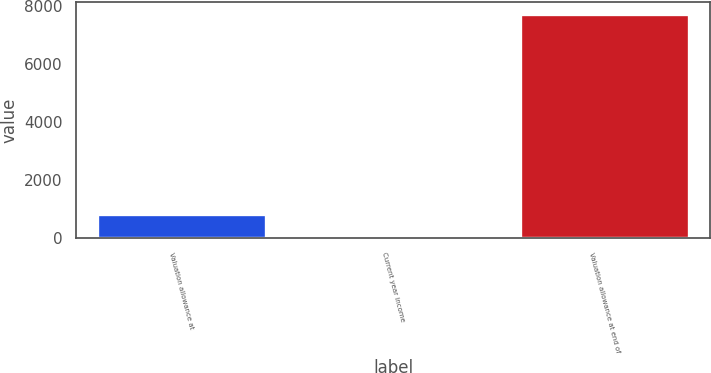Convert chart. <chart><loc_0><loc_0><loc_500><loc_500><bar_chart><fcel>Valuation allowance at<fcel>Current year income<fcel>Valuation allowance at end of<nl><fcel>832.8<fcel>65<fcel>7743<nl></chart> 